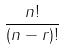Convert formula to latex. <formula><loc_0><loc_0><loc_500><loc_500>\frac { n ! } { ( n - r ) ! }</formula> 